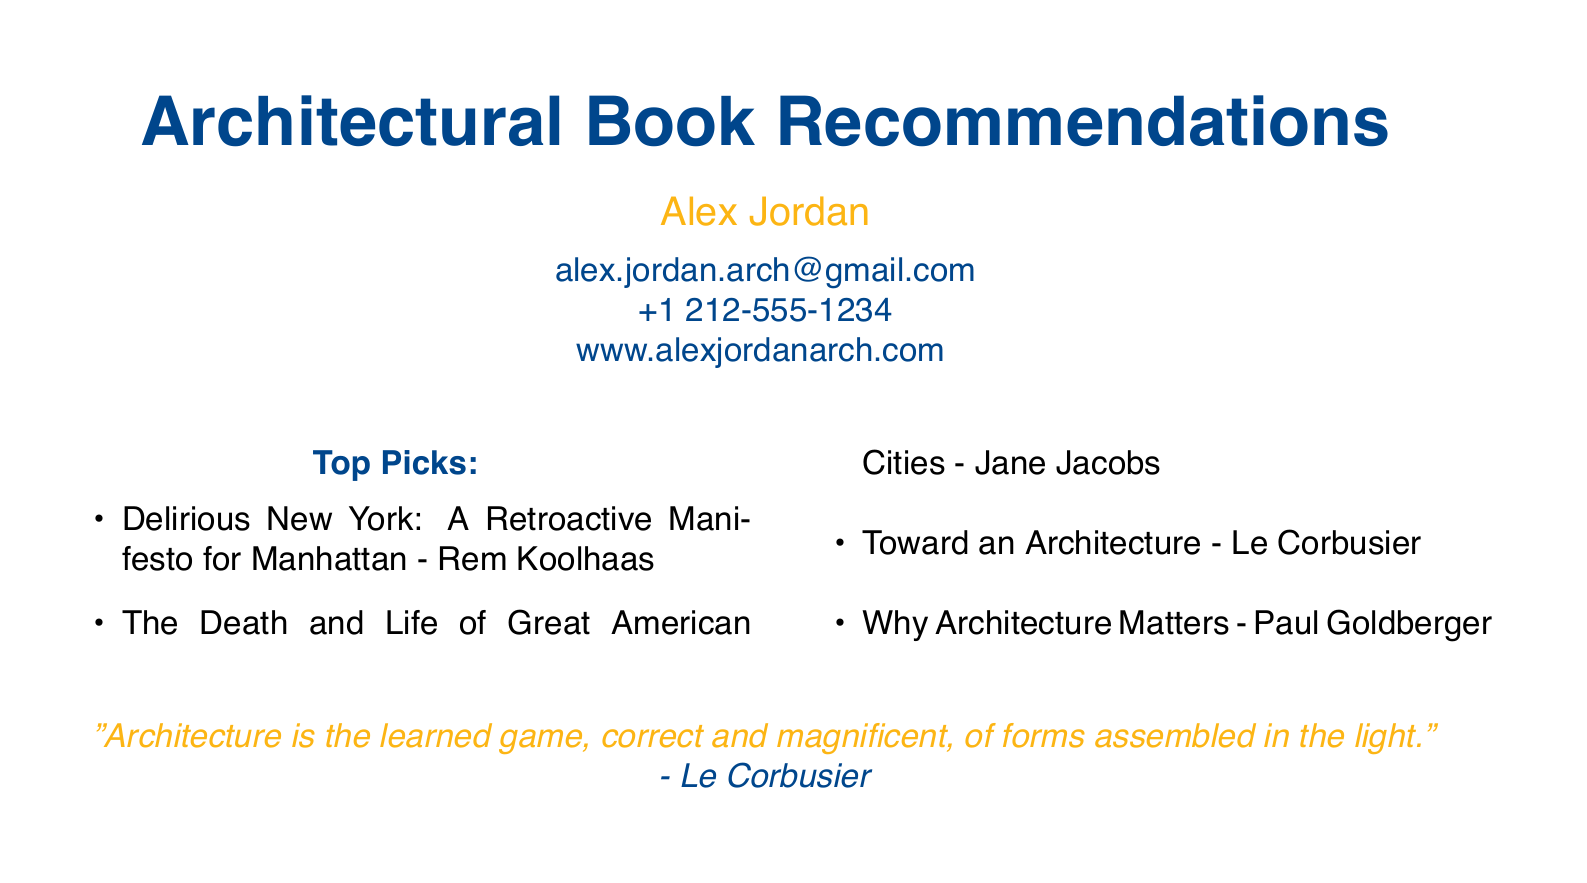What is the name of the person on the card? The name of the person is stated prominently at the center of the document.
Answer: Alex Jordan What is the email address listed? The email address is presented below the name, providing contact information.
Answer: alex.jordan.arch@gmail.com How many top picks are listed in the recommendations? The number of items in the list of top picks can be counted in the document.
Answer: 4 Who is the author of "Delirious New York: A Retroactive Manifesto for Manhattan"? The author is mentioned alongside the book title in the list of top picks.
Answer: Rem Koolhaas What color is used for the quotes in the document? The document uses a specific color for the quotes, identifiable by its color description.
Answer: nycgold Which architect wrote "The Death and Life of Great American Cities"? This question requires identifying the author associated with a specific book title in the document.
Answer: Jane Jacobs What does Le Corbusier say about architecture in the quote? The quote captures a philosophical view of architecture and is attributed to Le Corbusier.
Answer: "Architecture is the learned game, correct and magnificent, of forms assembled in the light." What type of document is this? The characteristics of the document indicate its specific purpose in conveying personal recommendations.
Answer: Business card 